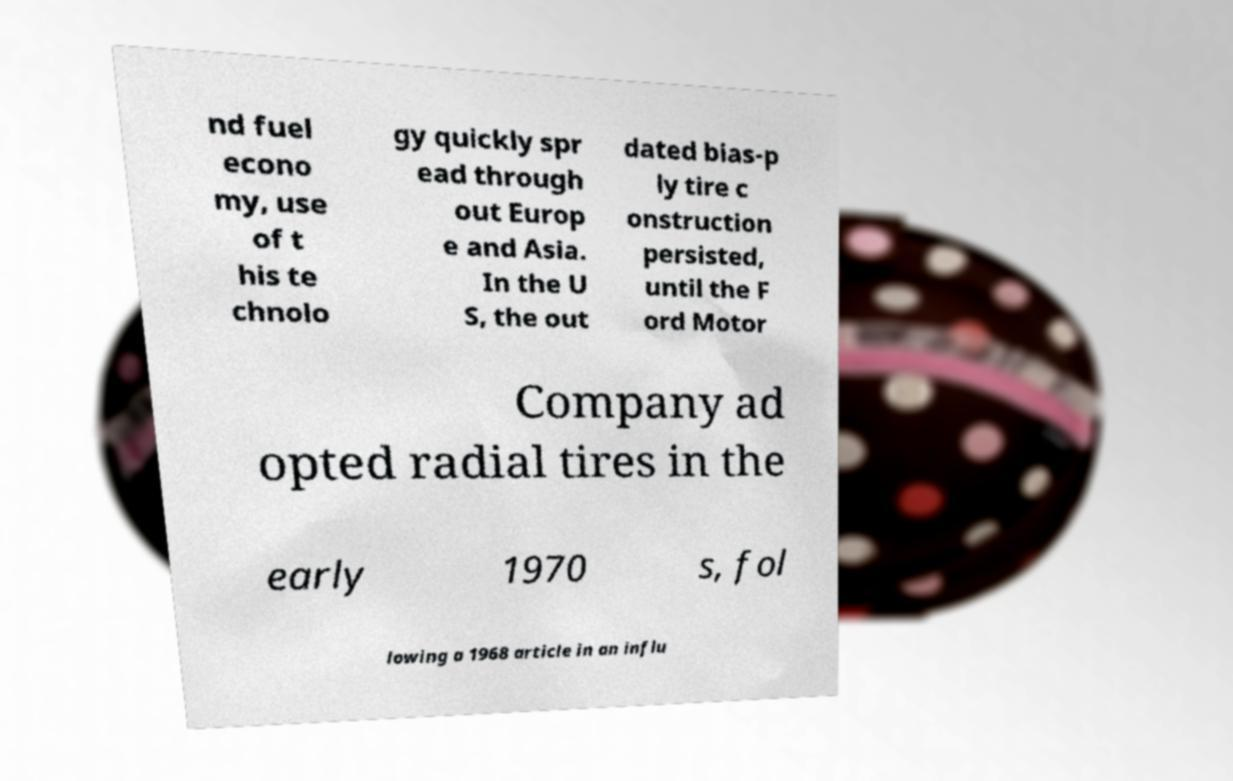Can you accurately transcribe the text from the provided image for me? nd fuel econo my, use of t his te chnolo gy quickly spr ead through out Europ e and Asia. In the U S, the out dated bias-p ly tire c onstruction persisted, until the F ord Motor Company ad opted radial tires in the early 1970 s, fol lowing a 1968 article in an influ 